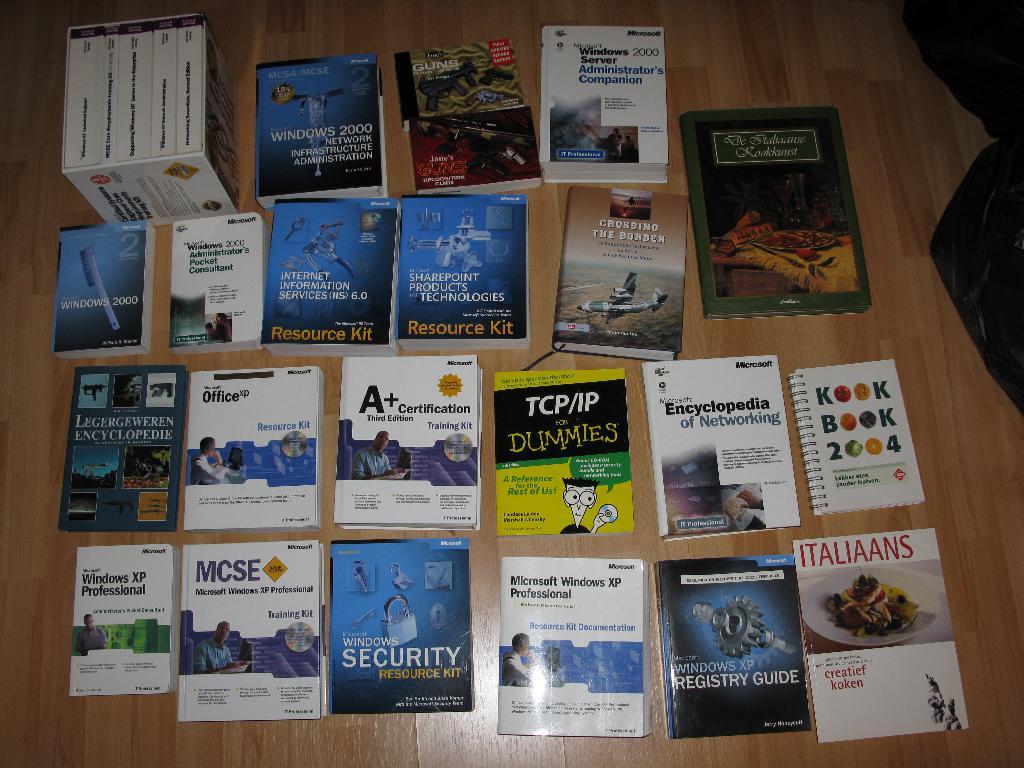What for dummies?
Offer a very short reply. Tcp/ip. 